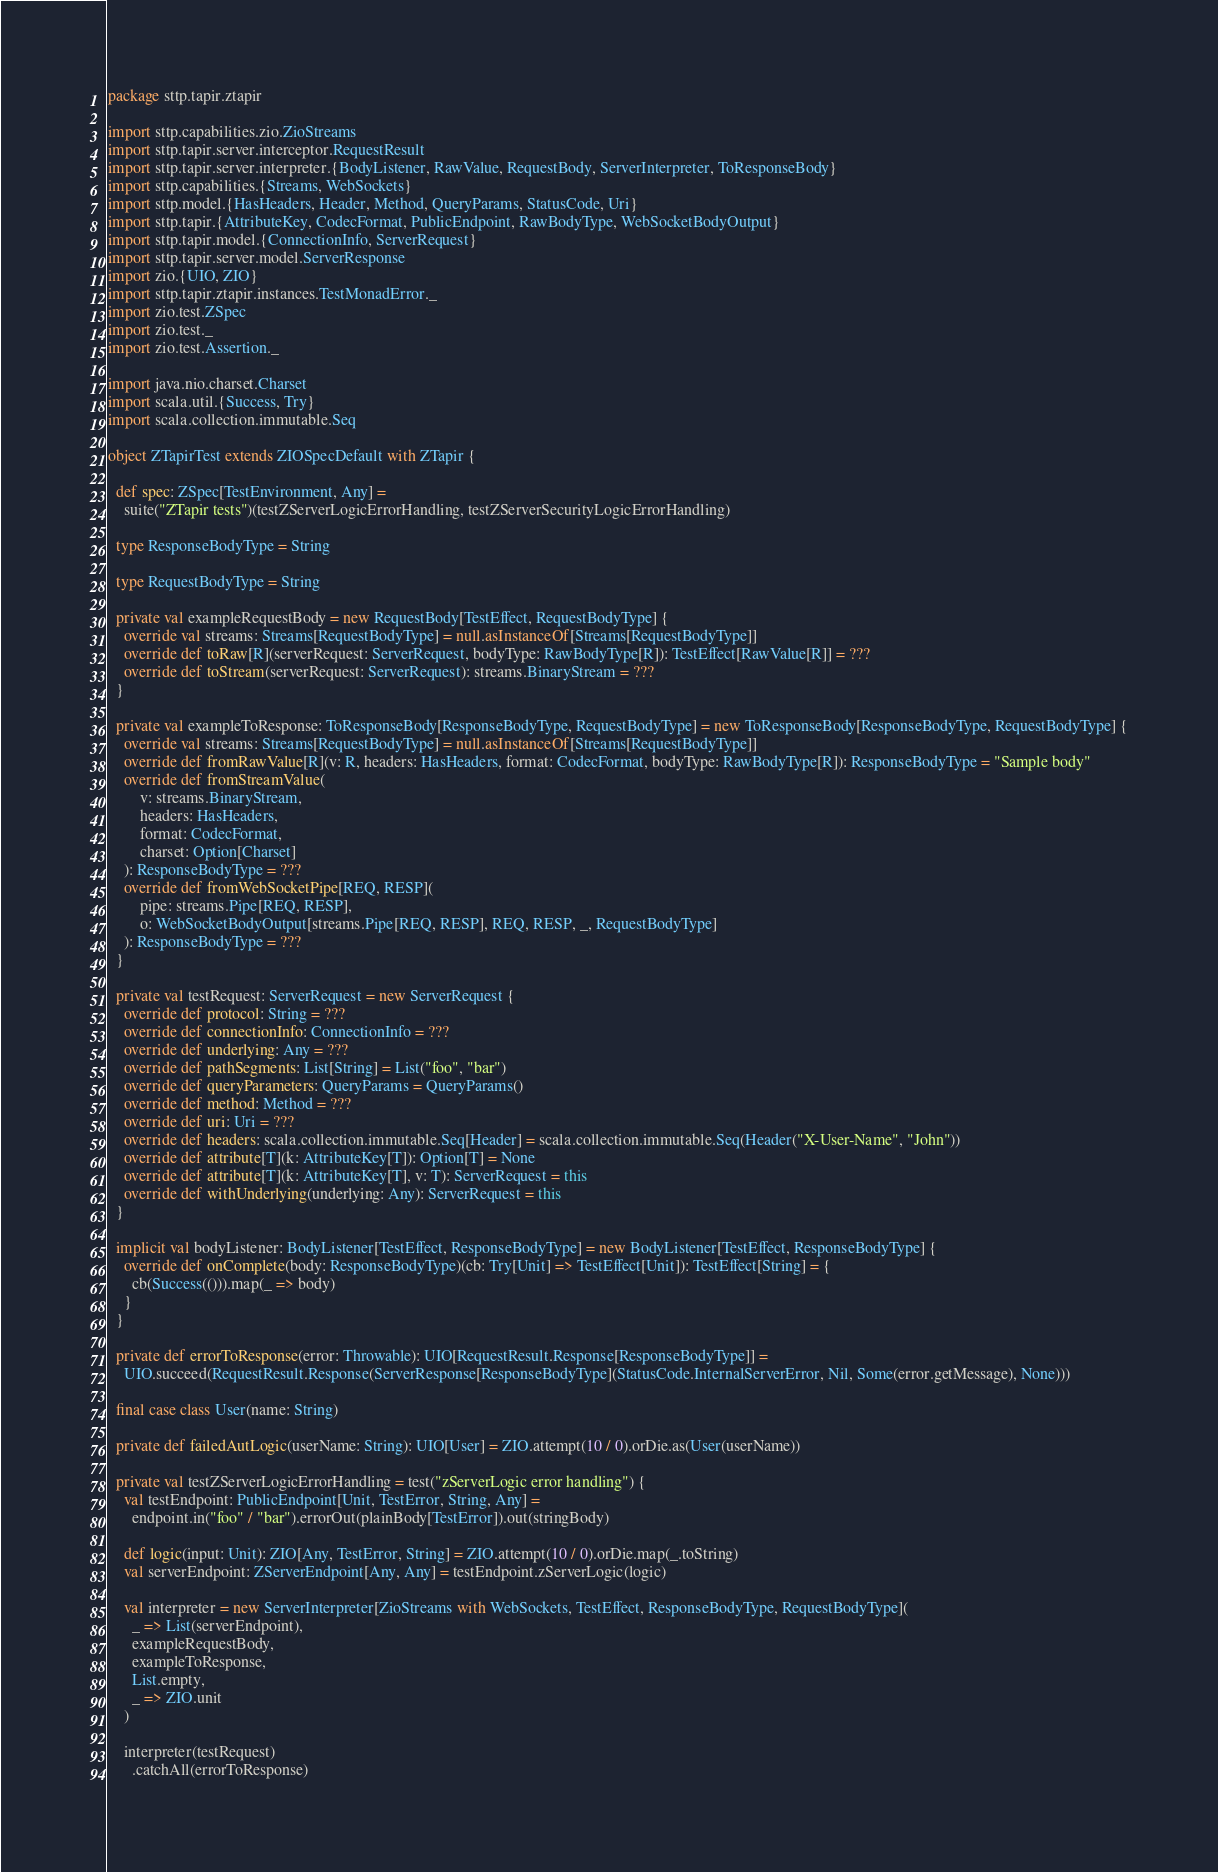Convert code to text. <code><loc_0><loc_0><loc_500><loc_500><_Scala_>package sttp.tapir.ztapir

import sttp.capabilities.zio.ZioStreams
import sttp.tapir.server.interceptor.RequestResult
import sttp.tapir.server.interpreter.{BodyListener, RawValue, RequestBody, ServerInterpreter, ToResponseBody}
import sttp.capabilities.{Streams, WebSockets}
import sttp.model.{HasHeaders, Header, Method, QueryParams, StatusCode, Uri}
import sttp.tapir.{AttributeKey, CodecFormat, PublicEndpoint, RawBodyType, WebSocketBodyOutput}
import sttp.tapir.model.{ConnectionInfo, ServerRequest}
import sttp.tapir.server.model.ServerResponse
import zio.{UIO, ZIO}
import sttp.tapir.ztapir.instances.TestMonadError._
import zio.test.ZSpec
import zio.test._
import zio.test.Assertion._

import java.nio.charset.Charset
import scala.util.{Success, Try}
import scala.collection.immutable.Seq

object ZTapirTest extends ZIOSpecDefault with ZTapir {

  def spec: ZSpec[TestEnvironment, Any] =
    suite("ZTapir tests")(testZServerLogicErrorHandling, testZServerSecurityLogicErrorHandling)

  type ResponseBodyType = String

  type RequestBodyType = String

  private val exampleRequestBody = new RequestBody[TestEffect, RequestBodyType] {
    override val streams: Streams[RequestBodyType] = null.asInstanceOf[Streams[RequestBodyType]]
    override def toRaw[R](serverRequest: ServerRequest, bodyType: RawBodyType[R]): TestEffect[RawValue[R]] = ???
    override def toStream(serverRequest: ServerRequest): streams.BinaryStream = ???
  }

  private val exampleToResponse: ToResponseBody[ResponseBodyType, RequestBodyType] = new ToResponseBody[ResponseBodyType, RequestBodyType] {
    override val streams: Streams[RequestBodyType] = null.asInstanceOf[Streams[RequestBodyType]]
    override def fromRawValue[R](v: R, headers: HasHeaders, format: CodecFormat, bodyType: RawBodyType[R]): ResponseBodyType = "Sample body"
    override def fromStreamValue(
        v: streams.BinaryStream,
        headers: HasHeaders,
        format: CodecFormat,
        charset: Option[Charset]
    ): ResponseBodyType = ???
    override def fromWebSocketPipe[REQ, RESP](
        pipe: streams.Pipe[REQ, RESP],
        o: WebSocketBodyOutput[streams.Pipe[REQ, RESP], REQ, RESP, _, RequestBodyType]
    ): ResponseBodyType = ???
  }

  private val testRequest: ServerRequest = new ServerRequest {
    override def protocol: String = ???
    override def connectionInfo: ConnectionInfo = ???
    override def underlying: Any = ???
    override def pathSegments: List[String] = List("foo", "bar")
    override def queryParameters: QueryParams = QueryParams()
    override def method: Method = ???
    override def uri: Uri = ???
    override def headers: scala.collection.immutable.Seq[Header] = scala.collection.immutable.Seq(Header("X-User-Name", "John"))
    override def attribute[T](k: AttributeKey[T]): Option[T] = None
    override def attribute[T](k: AttributeKey[T], v: T): ServerRequest = this
    override def withUnderlying(underlying: Any): ServerRequest = this
  }

  implicit val bodyListener: BodyListener[TestEffect, ResponseBodyType] = new BodyListener[TestEffect, ResponseBodyType] {
    override def onComplete(body: ResponseBodyType)(cb: Try[Unit] => TestEffect[Unit]): TestEffect[String] = {
      cb(Success(())).map(_ => body)
    }
  }

  private def errorToResponse(error: Throwable): UIO[RequestResult.Response[ResponseBodyType]] =
    UIO.succeed(RequestResult.Response(ServerResponse[ResponseBodyType](StatusCode.InternalServerError, Nil, Some(error.getMessage), None)))

  final case class User(name: String)

  private def failedAutLogic(userName: String): UIO[User] = ZIO.attempt(10 / 0).orDie.as(User(userName))

  private val testZServerLogicErrorHandling = test("zServerLogic error handling") {
    val testEndpoint: PublicEndpoint[Unit, TestError, String, Any] =
      endpoint.in("foo" / "bar").errorOut(plainBody[TestError]).out(stringBody)

    def logic(input: Unit): ZIO[Any, TestError, String] = ZIO.attempt(10 / 0).orDie.map(_.toString)
    val serverEndpoint: ZServerEndpoint[Any, Any] = testEndpoint.zServerLogic(logic)

    val interpreter = new ServerInterpreter[ZioStreams with WebSockets, TestEffect, ResponseBodyType, RequestBodyType](
      _ => List(serverEndpoint),
      exampleRequestBody,
      exampleToResponse,
      List.empty,
      _ => ZIO.unit
    )

    interpreter(testRequest)
      .catchAll(errorToResponse)</code> 